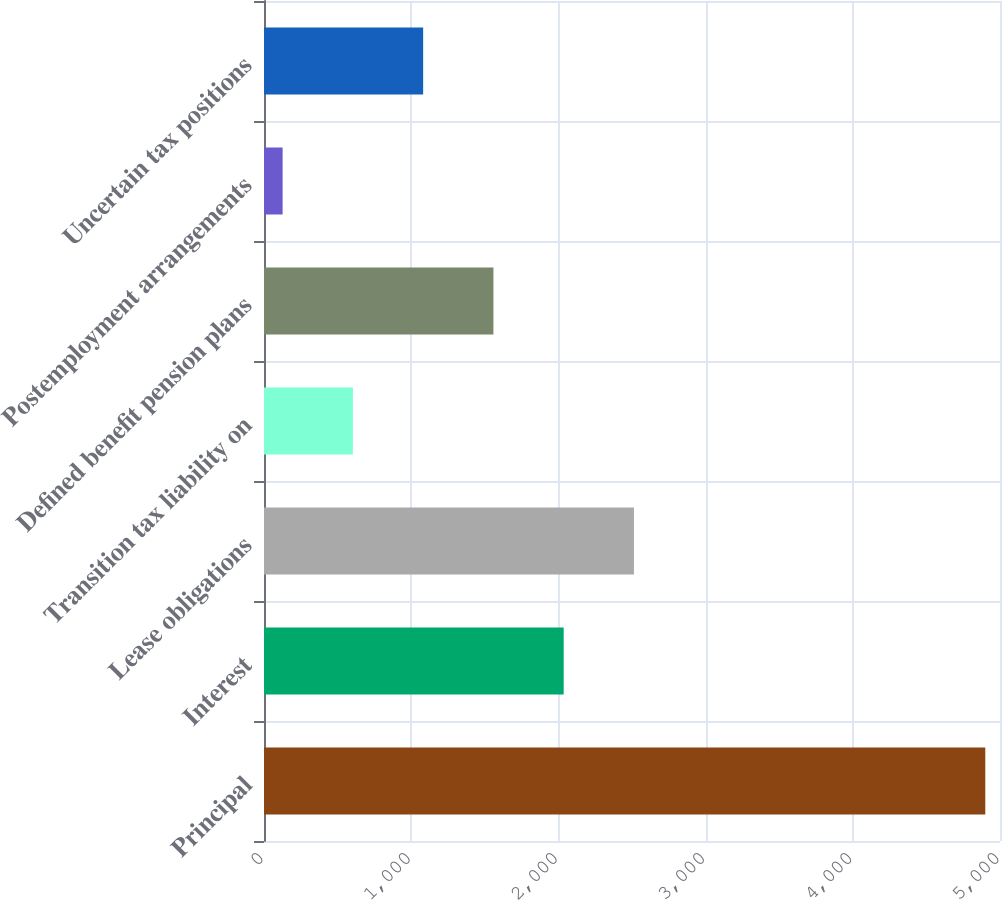Convert chart to OTSL. <chart><loc_0><loc_0><loc_500><loc_500><bar_chart><fcel>Principal<fcel>Interest<fcel>Lease obligations<fcel>Transition tax liability on<fcel>Defined benefit pension plans<fcel>Postemployment arrangements<fcel>Uncertain tax positions<nl><fcel>4900<fcel>2035.9<fcel>2513.25<fcel>603.85<fcel>1558.55<fcel>126.5<fcel>1081.2<nl></chart> 